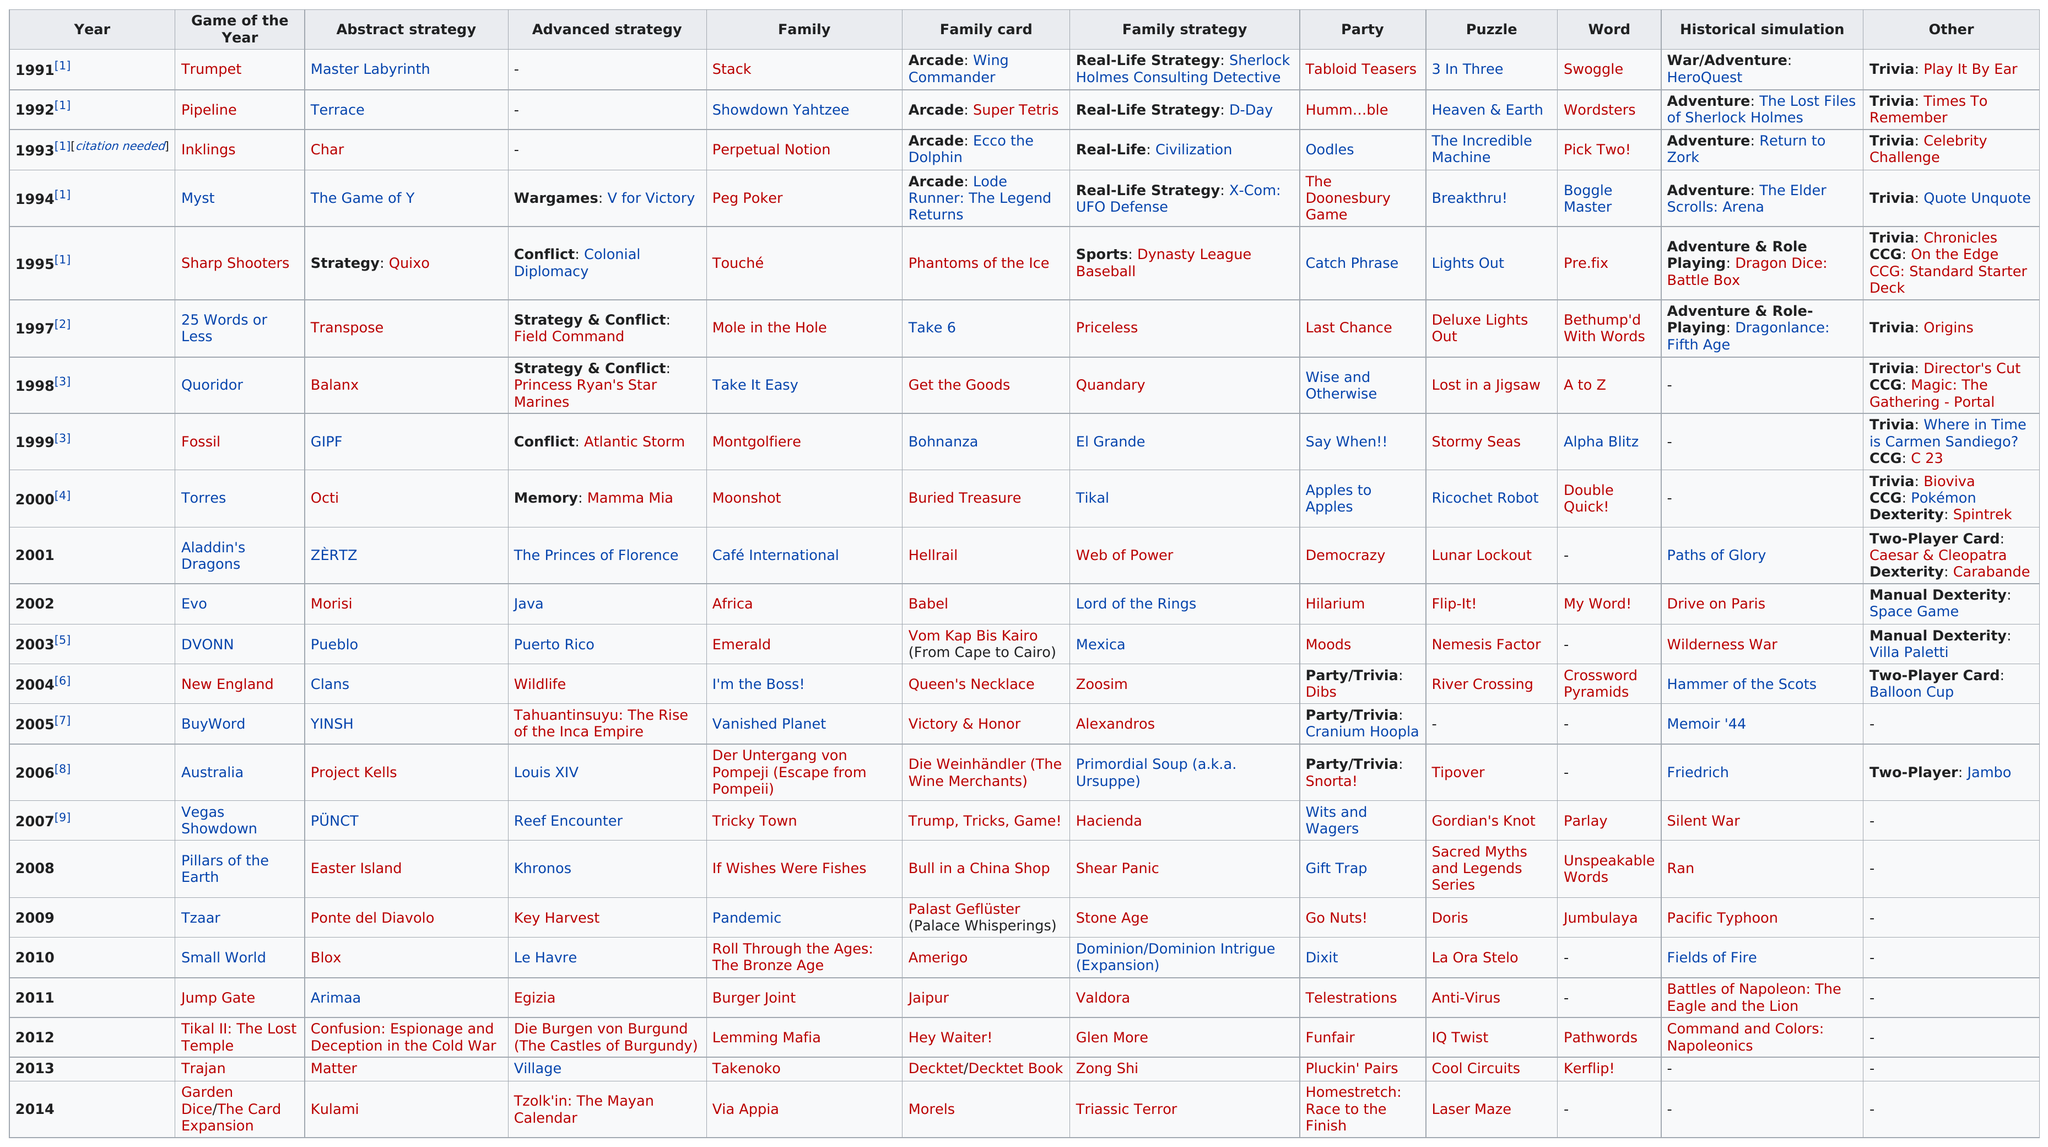Give some essential details in this illustration. A total of 23 years are represented in the chart. There are 22 puzzles on the chart. 1991 was a year that did not have an advanced military strategy. In my opinion, Myst was the better game of the year, followed closely by the Sharp Shooters game. In 1994, the game that came after Myst and was named Sharp Shooters is considered a notable title in the gaming industry. 